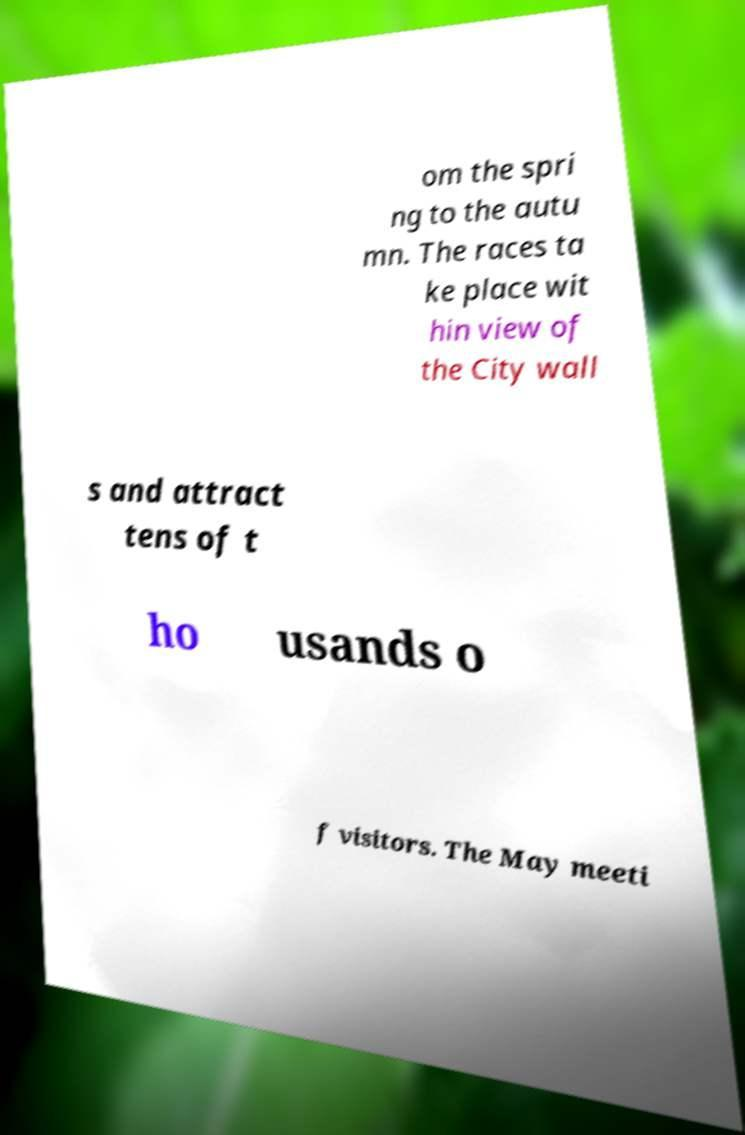Could you assist in decoding the text presented in this image and type it out clearly? om the spri ng to the autu mn. The races ta ke place wit hin view of the City wall s and attract tens of t ho usands o f visitors. The May meeti 